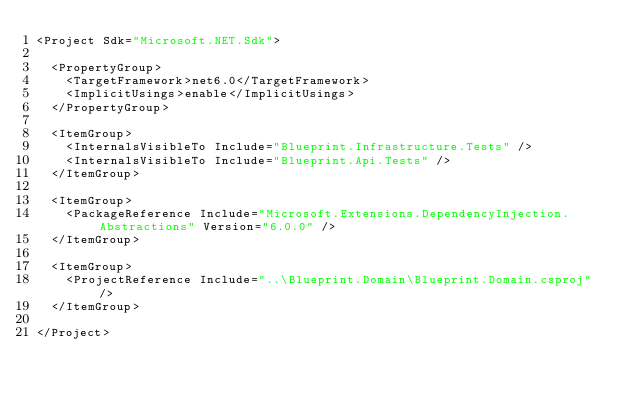<code> <loc_0><loc_0><loc_500><loc_500><_XML_><Project Sdk="Microsoft.NET.Sdk">

  <PropertyGroup>
    <TargetFramework>net6.0</TargetFramework>
	<ImplicitUsings>enable</ImplicitUsings>
  </PropertyGroup>

  <ItemGroup>
	<InternalsVisibleTo Include="Blueprint.Infrastructure.Tests" />
	<InternalsVisibleTo Include="Blueprint.Api.Tests" />
  </ItemGroup>

  <ItemGroup>
    <PackageReference Include="Microsoft.Extensions.DependencyInjection.Abstractions" Version="6.0.0" />
  </ItemGroup>

  <ItemGroup>
    <ProjectReference Include="..\Blueprint.Domain\Blueprint.Domain.csproj" />
  </ItemGroup>

</Project></code> 